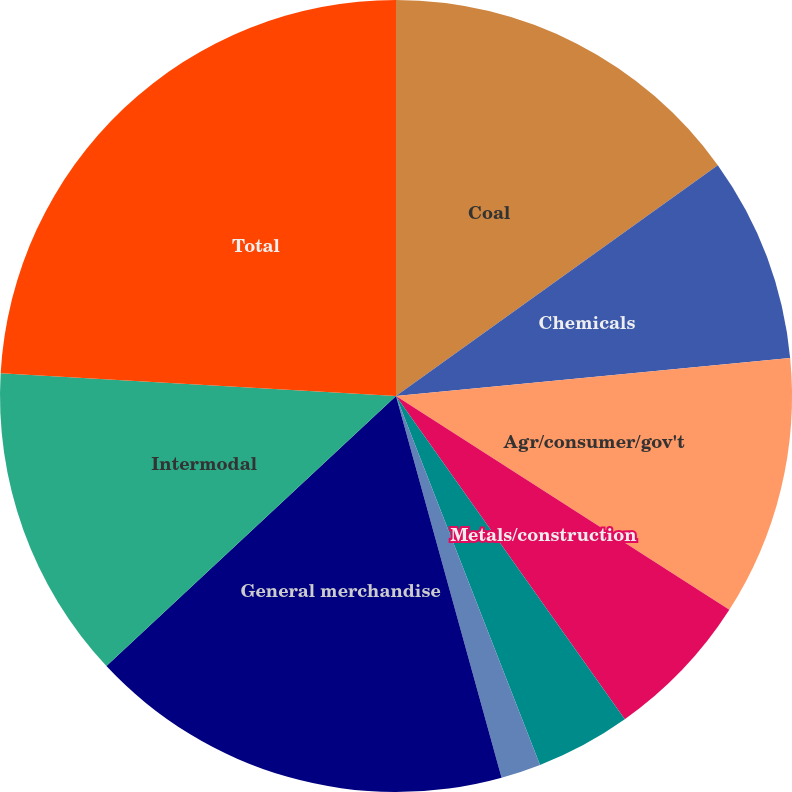Convert chart. <chart><loc_0><loc_0><loc_500><loc_500><pie_chart><fcel>Coal<fcel>Chemicals<fcel>Agr/consumer/gov't<fcel>Metals/construction<fcel>Automotive<fcel>Paper/clay/forest<fcel>General merchandise<fcel>Intermodal<fcel>Total<nl><fcel>15.1%<fcel>8.37%<fcel>10.61%<fcel>6.12%<fcel>3.88%<fcel>1.63%<fcel>17.35%<fcel>12.86%<fcel>24.09%<nl></chart> 